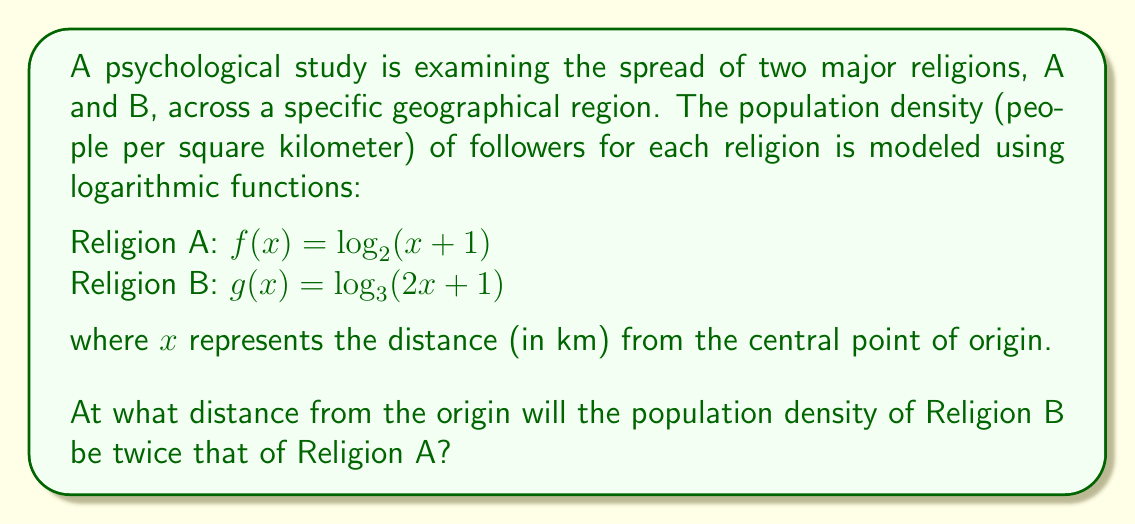What is the answer to this math problem? Let's approach this step-by-step:

1) We need to find $x$ where $g(x) = 2f(x)$

2) Substituting the given functions:
   $\log_3(2x + 1) = 2\log_2(x + 1)$

3) Using the change of base formula, we can convert $\log_2$ to $\log_3$:
   $\log_3(2x + 1) = 2 \cdot \frac{\log_3(x + 1)}{\log_3(2)}$

4) Now we have:
   $\log_3(2x + 1) = \frac{2\log_3(x + 1)}{\log_3(2)}$

5) Apply the exponential function (base 3) to both sides:
   $2x + 1 = (x + 1)^{\frac{2}{\log_3(2)}}$

6) Let $a = \frac{2}{\log_3(2)}$. Then we have:
   $2x + 1 = (x + 1)^a$

7) This equation cannot be solved algebraically. We need to use numerical methods or graphing to find the solution.

8) Using a graphing calculator or software, we can find that the solution is approximately:
   $x \approx 2.513$

Therefore, the population density of Religion B will be twice that of Religion A at approximately 2.513 km from the origin.
Answer: 2.513 km 